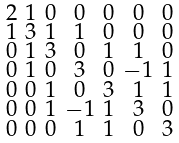Convert formula to latex. <formula><loc_0><loc_0><loc_500><loc_500>\begin{smallmatrix} 2 & 1 & 0 & 0 & 0 & 0 & 0 \\ 1 & 3 & 1 & 1 & 0 & 0 & 0 \\ 0 & 1 & 3 & 0 & 1 & 1 & 0 \\ 0 & 1 & 0 & 3 & 0 & - 1 & 1 \\ 0 & 0 & 1 & 0 & 3 & 1 & 1 \\ 0 & 0 & 1 & - 1 & 1 & 3 & 0 \\ 0 & 0 & 0 & 1 & 1 & 0 & 3 \end{smallmatrix}</formula> 